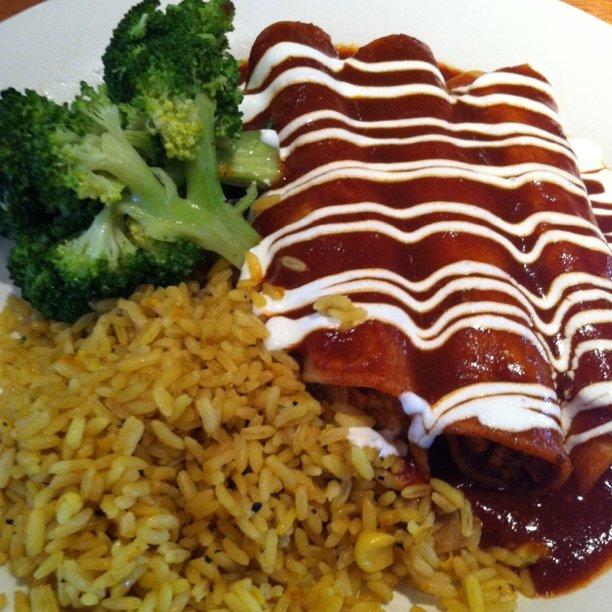What is the veggie on the plate?
Write a very short answer. Broccoli. Do you want some food?
Write a very short answer. Yes. Could this meal be Mexican?
Concise answer only. Yes. 